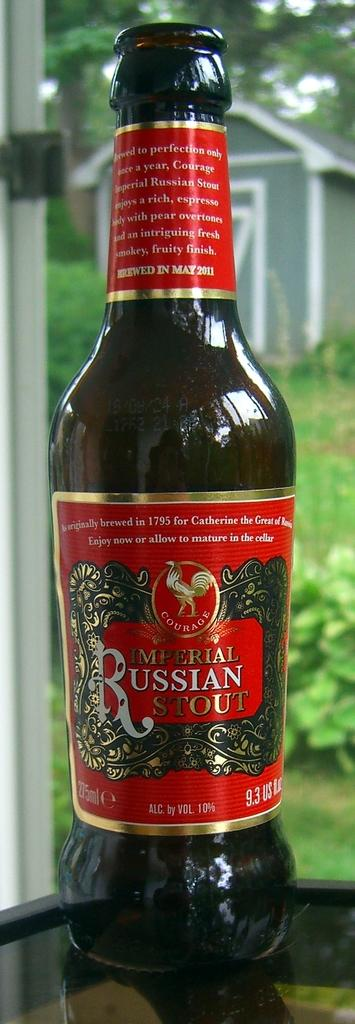<image>
Create a compact narrative representing the image presented. a russian drink that has liquid in it 